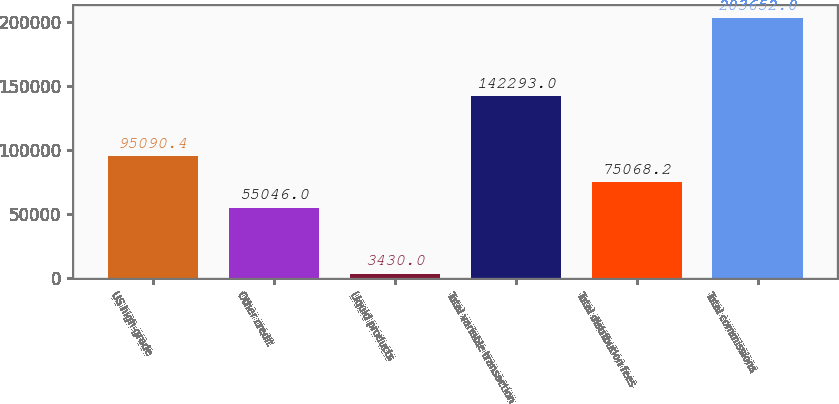Convert chart to OTSL. <chart><loc_0><loc_0><loc_500><loc_500><bar_chart><fcel>US high-grade<fcel>Other credit<fcel>Liquid products<fcel>Total variable transaction<fcel>Total distribution fees<fcel>Total commissions<nl><fcel>95090.4<fcel>55046<fcel>3430<fcel>142293<fcel>75068.2<fcel>203652<nl></chart> 